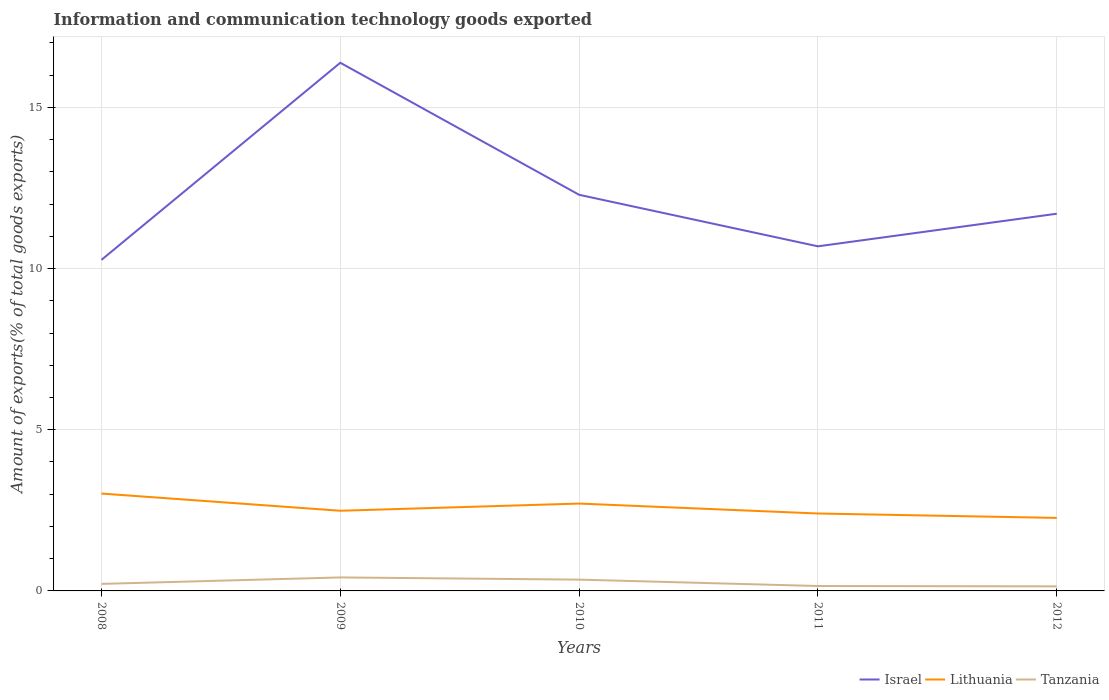Does the line corresponding to Israel intersect with the line corresponding to Tanzania?
Provide a short and direct response. No. Across all years, what is the maximum amount of goods exported in Israel?
Your answer should be very brief. 10.27. In which year was the amount of goods exported in Lithuania maximum?
Ensure brevity in your answer.  2012. What is the total amount of goods exported in Lithuania in the graph?
Keep it short and to the point. 0.44. What is the difference between the highest and the second highest amount of goods exported in Israel?
Your answer should be compact. 6.11. Is the amount of goods exported in Israel strictly greater than the amount of goods exported in Tanzania over the years?
Provide a succinct answer. No. How many lines are there?
Offer a very short reply. 3. How many years are there in the graph?
Provide a succinct answer. 5. What is the difference between two consecutive major ticks on the Y-axis?
Your answer should be compact. 5. Does the graph contain any zero values?
Your response must be concise. No. What is the title of the graph?
Ensure brevity in your answer.  Information and communication technology goods exported. What is the label or title of the X-axis?
Provide a short and direct response. Years. What is the label or title of the Y-axis?
Ensure brevity in your answer.  Amount of exports(% of total goods exports). What is the Amount of exports(% of total goods exports) in Israel in 2008?
Provide a succinct answer. 10.27. What is the Amount of exports(% of total goods exports) of Lithuania in 2008?
Your response must be concise. 3.02. What is the Amount of exports(% of total goods exports) in Tanzania in 2008?
Your response must be concise. 0.22. What is the Amount of exports(% of total goods exports) of Israel in 2009?
Make the answer very short. 16.38. What is the Amount of exports(% of total goods exports) in Lithuania in 2009?
Provide a short and direct response. 2.49. What is the Amount of exports(% of total goods exports) of Tanzania in 2009?
Your answer should be very brief. 0.42. What is the Amount of exports(% of total goods exports) of Israel in 2010?
Ensure brevity in your answer.  12.29. What is the Amount of exports(% of total goods exports) of Lithuania in 2010?
Keep it short and to the point. 2.71. What is the Amount of exports(% of total goods exports) in Tanzania in 2010?
Keep it short and to the point. 0.35. What is the Amount of exports(% of total goods exports) of Israel in 2011?
Keep it short and to the point. 10.69. What is the Amount of exports(% of total goods exports) of Lithuania in 2011?
Your answer should be very brief. 2.4. What is the Amount of exports(% of total goods exports) in Tanzania in 2011?
Your answer should be compact. 0.15. What is the Amount of exports(% of total goods exports) of Israel in 2012?
Keep it short and to the point. 11.7. What is the Amount of exports(% of total goods exports) in Lithuania in 2012?
Provide a succinct answer. 2.27. What is the Amount of exports(% of total goods exports) in Tanzania in 2012?
Your answer should be very brief. 0.14. Across all years, what is the maximum Amount of exports(% of total goods exports) in Israel?
Offer a terse response. 16.38. Across all years, what is the maximum Amount of exports(% of total goods exports) in Lithuania?
Make the answer very short. 3.02. Across all years, what is the maximum Amount of exports(% of total goods exports) in Tanzania?
Ensure brevity in your answer.  0.42. Across all years, what is the minimum Amount of exports(% of total goods exports) of Israel?
Provide a short and direct response. 10.27. Across all years, what is the minimum Amount of exports(% of total goods exports) of Lithuania?
Provide a succinct answer. 2.27. Across all years, what is the minimum Amount of exports(% of total goods exports) in Tanzania?
Offer a very short reply. 0.14. What is the total Amount of exports(% of total goods exports) of Israel in the graph?
Your response must be concise. 61.33. What is the total Amount of exports(% of total goods exports) in Lithuania in the graph?
Offer a terse response. 12.88. What is the total Amount of exports(% of total goods exports) of Tanzania in the graph?
Offer a terse response. 1.28. What is the difference between the Amount of exports(% of total goods exports) of Israel in 2008 and that in 2009?
Provide a succinct answer. -6.11. What is the difference between the Amount of exports(% of total goods exports) of Lithuania in 2008 and that in 2009?
Your response must be concise. 0.53. What is the difference between the Amount of exports(% of total goods exports) in Tanzania in 2008 and that in 2009?
Provide a short and direct response. -0.2. What is the difference between the Amount of exports(% of total goods exports) of Israel in 2008 and that in 2010?
Offer a terse response. -2.02. What is the difference between the Amount of exports(% of total goods exports) in Lithuania in 2008 and that in 2010?
Your answer should be compact. 0.31. What is the difference between the Amount of exports(% of total goods exports) of Tanzania in 2008 and that in 2010?
Offer a terse response. -0.13. What is the difference between the Amount of exports(% of total goods exports) of Israel in 2008 and that in 2011?
Your answer should be compact. -0.42. What is the difference between the Amount of exports(% of total goods exports) in Lithuania in 2008 and that in 2011?
Make the answer very short. 0.62. What is the difference between the Amount of exports(% of total goods exports) of Tanzania in 2008 and that in 2011?
Your response must be concise. 0.07. What is the difference between the Amount of exports(% of total goods exports) in Israel in 2008 and that in 2012?
Offer a terse response. -1.43. What is the difference between the Amount of exports(% of total goods exports) of Lithuania in 2008 and that in 2012?
Provide a succinct answer. 0.76. What is the difference between the Amount of exports(% of total goods exports) of Tanzania in 2008 and that in 2012?
Make the answer very short. 0.08. What is the difference between the Amount of exports(% of total goods exports) of Israel in 2009 and that in 2010?
Ensure brevity in your answer.  4.1. What is the difference between the Amount of exports(% of total goods exports) in Lithuania in 2009 and that in 2010?
Give a very brief answer. -0.22. What is the difference between the Amount of exports(% of total goods exports) in Tanzania in 2009 and that in 2010?
Provide a succinct answer. 0.07. What is the difference between the Amount of exports(% of total goods exports) of Israel in 2009 and that in 2011?
Your answer should be compact. 5.69. What is the difference between the Amount of exports(% of total goods exports) of Lithuania in 2009 and that in 2011?
Ensure brevity in your answer.  0.09. What is the difference between the Amount of exports(% of total goods exports) in Tanzania in 2009 and that in 2011?
Your answer should be compact. 0.27. What is the difference between the Amount of exports(% of total goods exports) of Israel in 2009 and that in 2012?
Offer a terse response. 4.68. What is the difference between the Amount of exports(% of total goods exports) of Lithuania in 2009 and that in 2012?
Ensure brevity in your answer.  0.22. What is the difference between the Amount of exports(% of total goods exports) in Tanzania in 2009 and that in 2012?
Your answer should be compact. 0.28. What is the difference between the Amount of exports(% of total goods exports) in Israel in 2010 and that in 2011?
Keep it short and to the point. 1.6. What is the difference between the Amount of exports(% of total goods exports) in Lithuania in 2010 and that in 2011?
Your answer should be very brief. 0.31. What is the difference between the Amount of exports(% of total goods exports) of Tanzania in 2010 and that in 2011?
Give a very brief answer. 0.2. What is the difference between the Amount of exports(% of total goods exports) in Israel in 2010 and that in 2012?
Your response must be concise. 0.59. What is the difference between the Amount of exports(% of total goods exports) of Lithuania in 2010 and that in 2012?
Your response must be concise. 0.44. What is the difference between the Amount of exports(% of total goods exports) in Tanzania in 2010 and that in 2012?
Offer a very short reply. 0.21. What is the difference between the Amount of exports(% of total goods exports) in Israel in 2011 and that in 2012?
Ensure brevity in your answer.  -1.01. What is the difference between the Amount of exports(% of total goods exports) in Lithuania in 2011 and that in 2012?
Give a very brief answer. 0.14. What is the difference between the Amount of exports(% of total goods exports) of Tanzania in 2011 and that in 2012?
Provide a short and direct response. 0.01. What is the difference between the Amount of exports(% of total goods exports) of Israel in 2008 and the Amount of exports(% of total goods exports) of Lithuania in 2009?
Provide a succinct answer. 7.78. What is the difference between the Amount of exports(% of total goods exports) in Israel in 2008 and the Amount of exports(% of total goods exports) in Tanzania in 2009?
Ensure brevity in your answer.  9.85. What is the difference between the Amount of exports(% of total goods exports) in Lithuania in 2008 and the Amount of exports(% of total goods exports) in Tanzania in 2009?
Make the answer very short. 2.6. What is the difference between the Amount of exports(% of total goods exports) in Israel in 2008 and the Amount of exports(% of total goods exports) in Lithuania in 2010?
Your response must be concise. 7.56. What is the difference between the Amount of exports(% of total goods exports) in Israel in 2008 and the Amount of exports(% of total goods exports) in Tanzania in 2010?
Your answer should be compact. 9.92. What is the difference between the Amount of exports(% of total goods exports) in Lithuania in 2008 and the Amount of exports(% of total goods exports) in Tanzania in 2010?
Give a very brief answer. 2.67. What is the difference between the Amount of exports(% of total goods exports) in Israel in 2008 and the Amount of exports(% of total goods exports) in Lithuania in 2011?
Give a very brief answer. 7.87. What is the difference between the Amount of exports(% of total goods exports) of Israel in 2008 and the Amount of exports(% of total goods exports) of Tanzania in 2011?
Provide a succinct answer. 10.12. What is the difference between the Amount of exports(% of total goods exports) in Lithuania in 2008 and the Amount of exports(% of total goods exports) in Tanzania in 2011?
Provide a short and direct response. 2.87. What is the difference between the Amount of exports(% of total goods exports) of Israel in 2008 and the Amount of exports(% of total goods exports) of Lithuania in 2012?
Your answer should be very brief. 8. What is the difference between the Amount of exports(% of total goods exports) in Israel in 2008 and the Amount of exports(% of total goods exports) in Tanzania in 2012?
Your response must be concise. 10.13. What is the difference between the Amount of exports(% of total goods exports) of Lithuania in 2008 and the Amount of exports(% of total goods exports) of Tanzania in 2012?
Provide a succinct answer. 2.88. What is the difference between the Amount of exports(% of total goods exports) in Israel in 2009 and the Amount of exports(% of total goods exports) in Lithuania in 2010?
Offer a terse response. 13.67. What is the difference between the Amount of exports(% of total goods exports) in Israel in 2009 and the Amount of exports(% of total goods exports) in Tanzania in 2010?
Your response must be concise. 16.03. What is the difference between the Amount of exports(% of total goods exports) in Lithuania in 2009 and the Amount of exports(% of total goods exports) in Tanzania in 2010?
Ensure brevity in your answer.  2.14. What is the difference between the Amount of exports(% of total goods exports) in Israel in 2009 and the Amount of exports(% of total goods exports) in Lithuania in 2011?
Provide a short and direct response. 13.98. What is the difference between the Amount of exports(% of total goods exports) of Israel in 2009 and the Amount of exports(% of total goods exports) of Tanzania in 2011?
Your response must be concise. 16.23. What is the difference between the Amount of exports(% of total goods exports) of Lithuania in 2009 and the Amount of exports(% of total goods exports) of Tanzania in 2011?
Give a very brief answer. 2.33. What is the difference between the Amount of exports(% of total goods exports) of Israel in 2009 and the Amount of exports(% of total goods exports) of Lithuania in 2012?
Give a very brief answer. 14.12. What is the difference between the Amount of exports(% of total goods exports) in Israel in 2009 and the Amount of exports(% of total goods exports) in Tanzania in 2012?
Your answer should be compact. 16.24. What is the difference between the Amount of exports(% of total goods exports) in Lithuania in 2009 and the Amount of exports(% of total goods exports) in Tanzania in 2012?
Your answer should be very brief. 2.34. What is the difference between the Amount of exports(% of total goods exports) of Israel in 2010 and the Amount of exports(% of total goods exports) of Lithuania in 2011?
Your answer should be compact. 9.89. What is the difference between the Amount of exports(% of total goods exports) of Israel in 2010 and the Amount of exports(% of total goods exports) of Tanzania in 2011?
Your answer should be very brief. 12.14. What is the difference between the Amount of exports(% of total goods exports) in Lithuania in 2010 and the Amount of exports(% of total goods exports) in Tanzania in 2011?
Your answer should be compact. 2.56. What is the difference between the Amount of exports(% of total goods exports) in Israel in 2010 and the Amount of exports(% of total goods exports) in Lithuania in 2012?
Keep it short and to the point. 10.02. What is the difference between the Amount of exports(% of total goods exports) in Israel in 2010 and the Amount of exports(% of total goods exports) in Tanzania in 2012?
Offer a very short reply. 12.15. What is the difference between the Amount of exports(% of total goods exports) of Lithuania in 2010 and the Amount of exports(% of total goods exports) of Tanzania in 2012?
Offer a terse response. 2.57. What is the difference between the Amount of exports(% of total goods exports) of Israel in 2011 and the Amount of exports(% of total goods exports) of Lithuania in 2012?
Your response must be concise. 8.42. What is the difference between the Amount of exports(% of total goods exports) of Israel in 2011 and the Amount of exports(% of total goods exports) of Tanzania in 2012?
Provide a succinct answer. 10.55. What is the difference between the Amount of exports(% of total goods exports) of Lithuania in 2011 and the Amount of exports(% of total goods exports) of Tanzania in 2012?
Your answer should be compact. 2.26. What is the average Amount of exports(% of total goods exports) of Israel per year?
Your answer should be compact. 12.27. What is the average Amount of exports(% of total goods exports) in Lithuania per year?
Your answer should be very brief. 2.58. What is the average Amount of exports(% of total goods exports) in Tanzania per year?
Offer a very short reply. 0.26. In the year 2008, what is the difference between the Amount of exports(% of total goods exports) of Israel and Amount of exports(% of total goods exports) of Lithuania?
Provide a succinct answer. 7.25. In the year 2008, what is the difference between the Amount of exports(% of total goods exports) of Israel and Amount of exports(% of total goods exports) of Tanzania?
Your answer should be compact. 10.05. In the year 2008, what is the difference between the Amount of exports(% of total goods exports) in Lithuania and Amount of exports(% of total goods exports) in Tanzania?
Give a very brief answer. 2.8. In the year 2009, what is the difference between the Amount of exports(% of total goods exports) in Israel and Amount of exports(% of total goods exports) in Lithuania?
Ensure brevity in your answer.  13.9. In the year 2009, what is the difference between the Amount of exports(% of total goods exports) of Israel and Amount of exports(% of total goods exports) of Tanzania?
Ensure brevity in your answer.  15.97. In the year 2009, what is the difference between the Amount of exports(% of total goods exports) of Lithuania and Amount of exports(% of total goods exports) of Tanzania?
Provide a short and direct response. 2.07. In the year 2010, what is the difference between the Amount of exports(% of total goods exports) in Israel and Amount of exports(% of total goods exports) in Lithuania?
Offer a very short reply. 9.58. In the year 2010, what is the difference between the Amount of exports(% of total goods exports) of Israel and Amount of exports(% of total goods exports) of Tanzania?
Give a very brief answer. 11.94. In the year 2010, what is the difference between the Amount of exports(% of total goods exports) of Lithuania and Amount of exports(% of total goods exports) of Tanzania?
Ensure brevity in your answer.  2.36. In the year 2011, what is the difference between the Amount of exports(% of total goods exports) in Israel and Amount of exports(% of total goods exports) in Lithuania?
Offer a very short reply. 8.29. In the year 2011, what is the difference between the Amount of exports(% of total goods exports) in Israel and Amount of exports(% of total goods exports) in Tanzania?
Give a very brief answer. 10.54. In the year 2011, what is the difference between the Amount of exports(% of total goods exports) in Lithuania and Amount of exports(% of total goods exports) in Tanzania?
Give a very brief answer. 2.25. In the year 2012, what is the difference between the Amount of exports(% of total goods exports) of Israel and Amount of exports(% of total goods exports) of Lithuania?
Offer a terse response. 9.44. In the year 2012, what is the difference between the Amount of exports(% of total goods exports) of Israel and Amount of exports(% of total goods exports) of Tanzania?
Give a very brief answer. 11.56. In the year 2012, what is the difference between the Amount of exports(% of total goods exports) in Lithuania and Amount of exports(% of total goods exports) in Tanzania?
Give a very brief answer. 2.12. What is the ratio of the Amount of exports(% of total goods exports) in Israel in 2008 to that in 2009?
Keep it short and to the point. 0.63. What is the ratio of the Amount of exports(% of total goods exports) of Lithuania in 2008 to that in 2009?
Offer a very short reply. 1.21. What is the ratio of the Amount of exports(% of total goods exports) of Tanzania in 2008 to that in 2009?
Keep it short and to the point. 0.52. What is the ratio of the Amount of exports(% of total goods exports) of Israel in 2008 to that in 2010?
Make the answer very short. 0.84. What is the ratio of the Amount of exports(% of total goods exports) of Lithuania in 2008 to that in 2010?
Offer a terse response. 1.11. What is the ratio of the Amount of exports(% of total goods exports) in Tanzania in 2008 to that in 2010?
Offer a terse response. 0.62. What is the ratio of the Amount of exports(% of total goods exports) of Israel in 2008 to that in 2011?
Offer a terse response. 0.96. What is the ratio of the Amount of exports(% of total goods exports) of Lithuania in 2008 to that in 2011?
Your answer should be very brief. 1.26. What is the ratio of the Amount of exports(% of total goods exports) of Tanzania in 2008 to that in 2011?
Your answer should be compact. 1.43. What is the ratio of the Amount of exports(% of total goods exports) in Israel in 2008 to that in 2012?
Make the answer very short. 0.88. What is the ratio of the Amount of exports(% of total goods exports) in Lithuania in 2008 to that in 2012?
Give a very brief answer. 1.33. What is the ratio of the Amount of exports(% of total goods exports) of Tanzania in 2008 to that in 2012?
Your response must be concise. 1.53. What is the ratio of the Amount of exports(% of total goods exports) in Israel in 2009 to that in 2010?
Offer a terse response. 1.33. What is the ratio of the Amount of exports(% of total goods exports) of Lithuania in 2009 to that in 2010?
Offer a terse response. 0.92. What is the ratio of the Amount of exports(% of total goods exports) in Tanzania in 2009 to that in 2010?
Offer a very short reply. 1.19. What is the ratio of the Amount of exports(% of total goods exports) in Israel in 2009 to that in 2011?
Your answer should be very brief. 1.53. What is the ratio of the Amount of exports(% of total goods exports) in Lithuania in 2009 to that in 2011?
Ensure brevity in your answer.  1.04. What is the ratio of the Amount of exports(% of total goods exports) of Tanzania in 2009 to that in 2011?
Provide a succinct answer. 2.75. What is the ratio of the Amount of exports(% of total goods exports) of Israel in 2009 to that in 2012?
Provide a short and direct response. 1.4. What is the ratio of the Amount of exports(% of total goods exports) in Lithuania in 2009 to that in 2012?
Give a very brief answer. 1.1. What is the ratio of the Amount of exports(% of total goods exports) in Tanzania in 2009 to that in 2012?
Your response must be concise. 2.94. What is the ratio of the Amount of exports(% of total goods exports) of Israel in 2010 to that in 2011?
Ensure brevity in your answer.  1.15. What is the ratio of the Amount of exports(% of total goods exports) of Lithuania in 2010 to that in 2011?
Give a very brief answer. 1.13. What is the ratio of the Amount of exports(% of total goods exports) in Tanzania in 2010 to that in 2011?
Your answer should be compact. 2.31. What is the ratio of the Amount of exports(% of total goods exports) of Israel in 2010 to that in 2012?
Ensure brevity in your answer.  1.05. What is the ratio of the Amount of exports(% of total goods exports) in Lithuania in 2010 to that in 2012?
Your answer should be very brief. 1.2. What is the ratio of the Amount of exports(% of total goods exports) in Tanzania in 2010 to that in 2012?
Make the answer very short. 2.47. What is the ratio of the Amount of exports(% of total goods exports) of Israel in 2011 to that in 2012?
Offer a very short reply. 0.91. What is the ratio of the Amount of exports(% of total goods exports) in Lithuania in 2011 to that in 2012?
Offer a terse response. 1.06. What is the ratio of the Amount of exports(% of total goods exports) in Tanzania in 2011 to that in 2012?
Your answer should be very brief. 1.07. What is the difference between the highest and the second highest Amount of exports(% of total goods exports) of Israel?
Ensure brevity in your answer.  4.1. What is the difference between the highest and the second highest Amount of exports(% of total goods exports) in Lithuania?
Your response must be concise. 0.31. What is the difference between the highest and the second highest Amount of exports(% of total goods exports) in Tanzania?
Your answer should be very brief. 0.07. What is the difference between the highest and the lowest Amount of exports(% of total goods exports) of Israel?
Give a very brief answer. 6.11. What is the difference between the highest and the lowest Amount of exports(% of total goods exports) in Lithuania?
Your response must be concise. 0.76. What is the difference between the highest and the lowest Amount of exports(% of total goods exports) of Tanzania?
Your answer should be very brief. 0.28. 